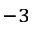Convert formula to latex. <formula><loc_0><loc_0><loc_500><loc_500>^ { - 3 }</formula> 